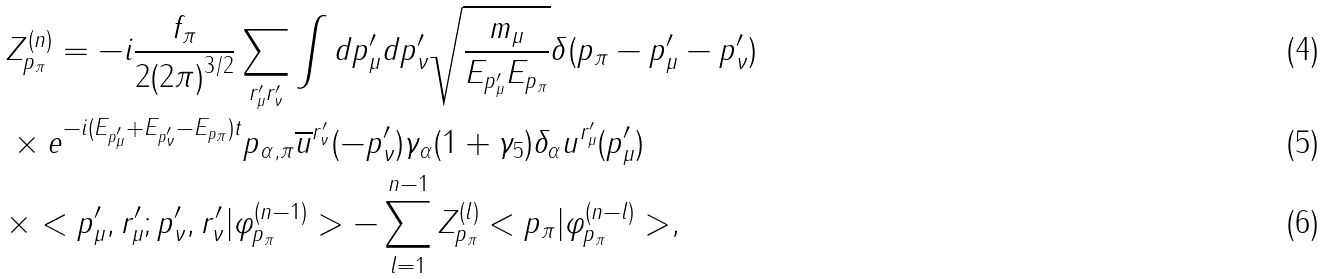Convert formula to latex. <formula><loc_0><loc_0><loc_500><loc_500>& Z _ { p _ { \pi } } ^ { ( n ) } = - i \frac { f _ { \pi } } { 2 { ( 2 \pi ) } ^ { 3 / 2 } } \sum _ { r _ { \mu } ^ { \prime } r _ { \nu } ^ { \prime } } \int d p ^ { \prime } _ { \mu } d p ^ { \prime } _ { \nu } \sqrt { \frac { m _ { \mu } } { E _ { p ^ { \prime } _ { \mu } } E _ { p _ { \pi } } } } \delta ( p _ { \pi } - p ^ { \prime } _ { \mu } - p ^ { \prime } _ { \nu } ) \\ & \times e ^ { - i ( E _ { p ^ { \prime } _ { \mu } } + E _ { p ^ { \prime } _ { \nu } } - E _ { p _ { \pi } } ) t } p _ { \alpha , \pi } \overline { u } ^ { r _ { \nu } ^ { \prime } } ( - { p } ^ { \prime } _ { \nu } ) \gamma _ { \alpha } ( 1 + \gamma _ { 5 } ) \delta _ { \alpha } u ^ { r _ { \mu } ^ { \prime } } ( p _ { \mu } ^ { \prime } ) \\ & \times < p ^ { \prime } _ { \mu } , r ^ { \prime } _ { \mu } ; p ^ { \prime } _ { \nu } , r ^ { \prime } _ { \nu } | \varphi _ { p _ { \pi } } ^ { ( n - 1 ) } > - \sum ^ { n - 1 } _ { l = 1 } Z _ { p _ { \pi } } ^ { ( l ) } < p _ { \pi } | \varphi _ { p _ { \pi } } ^ { ( n - l ) } > ,</formula> 